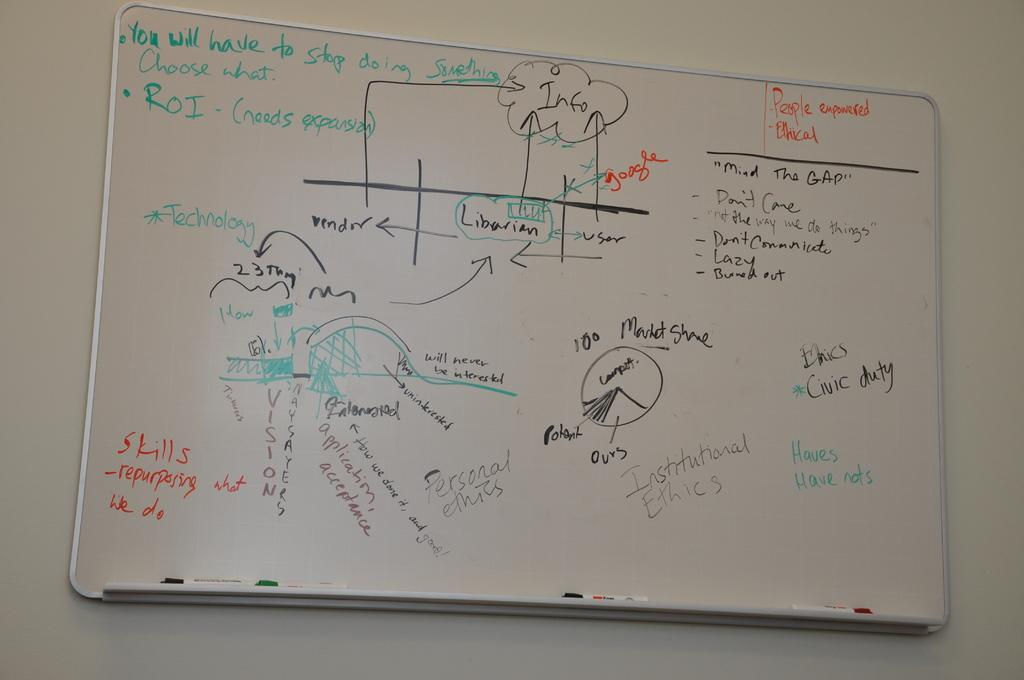<image>
Give a short and clear explanation of the subsequent image. A whiteboard says that you will have to stop doing something, and you should choose what. 